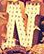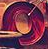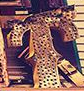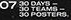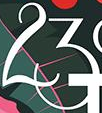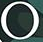What words can you see in these images in sequence, separated by a semicolon? N; O; T; #; 23; ° 